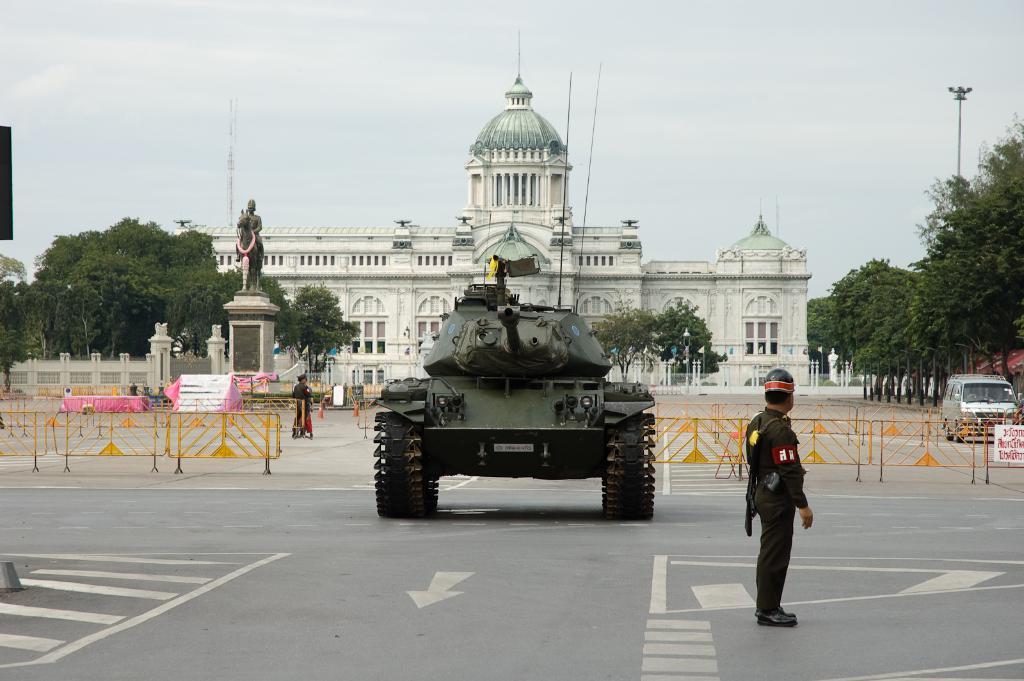Could you give a brief overview of what you see in this image? In this picture there is a vehicle in the center of the image, there is a palace in the center of the image, there are trees and boundaries on the right and left side of the image, there is a car on the right side of the image and there is a statue on the left side of the image, there is a man who is standing on the right side of the image. 